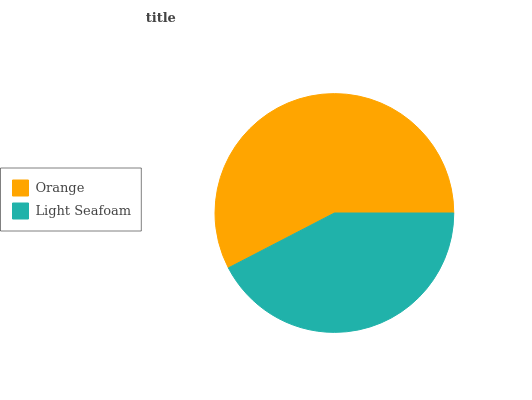Is Light Seafoam the minimum?
Answer yes or no. Yes. Is Orange the maximum?
Answer yes or no. Yes. Is Light Seafoam the maximum?
Answer yes or no. No. Is Orange greater than Light Seafoam?
Answer yes or no. Yes. Is Light Seafoam less than Orange?
Answer yes or no. Yes. Is Light Seafoam greater than Orange?
Answer yes or no. No. Is Orange less than Light Seafoam?
Answer yes or no. No. Is Orange the high median?
Answer yes or no. Yes. Is Light Seafoam the low median?
Answer yes or no. Yes. Is Light Seafoam the high median?
Answer yes or no. No. Is Orange the low median?
Answer yes or no. No. 